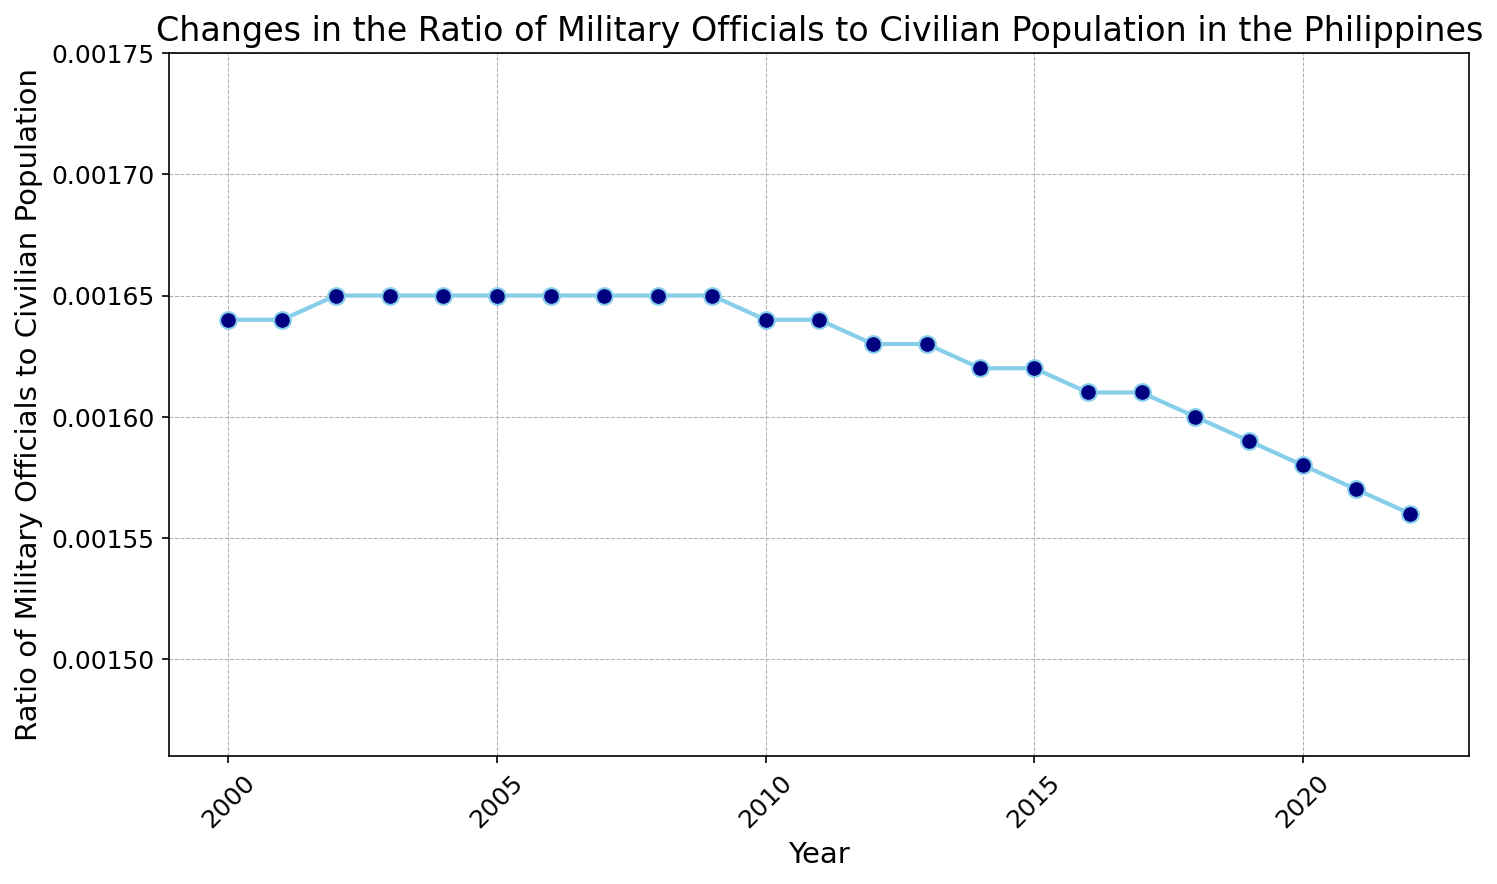What is the ratio of military officials to civilian population in 2005? Locate the year 2005 on the x-axis and find the corresponding ratio on the y-axis, which is marked by a point.
Answer: 0.00165 In which year did the ratio first decline after 2010? Locate the year 2010 on the x-axis and observe the trend in the ratio line. The first decline after 2010 is seen in 2012.
Answer: 2012 Is the ratio of military officials to civilian population higher in 2008 or 2020? Compare the y-axis values for the years 2008 and 2020. The ratio in 2008 is higher than in 2020.
Answer: 2008 What is the overall trend observed in the ratio from 2000 to 2022? Observe the overall direction of the line from 2000 to 2022. The trend shows a gradual decrease over the years.
Answer: Gradual decrease By how much did the ratio decrease from 2018 to 2022? Find the ratios for 2018 and 2022. Subtract the ratio in 2022 (0.00156) from the ratio in 2018 (0.00160). The decrease is 0.00160 - 0.00156 = 0.00004.
Answer: 0.00004 During which periods does the ratio remain constant? Identify the periods where the y-axis values show no change. The ratio remains constant from 2002 to 2010 and from 2005 to 2008.
Answer: 2002-2010 and 2005-2008 How does the ratio of military officials to civilian population in 2015 compare to that in 2021? Find and compare the y-axis values for 2015 and 2021. The ratio in 2015 (0.00162) is higher than in 2021 (0.00157).
Answer: Higher in 2015 Which year records the maximum ratio of military officials to civilian population? Locate the highest point on the line chart along the y-axis. The maximum ratio is recorded in 2003.
Answer: 2003 Does the ratio of military officials to civilian population show a sharp decline after a particular year? Examine the line chart for any steep downward slopes. A noticeable decline is seen after the year 2018.
Answer: 2018 What is the difference in the ratio from 2000 to 2022? Find the ratios for 2000 and 2022. Subtract the ratio in 2022 (0.00156) from the ratio in 2000 (0.00164). The difference is 0.00164 - 0.00156 = 0.00008.
Answer: 0.00008 